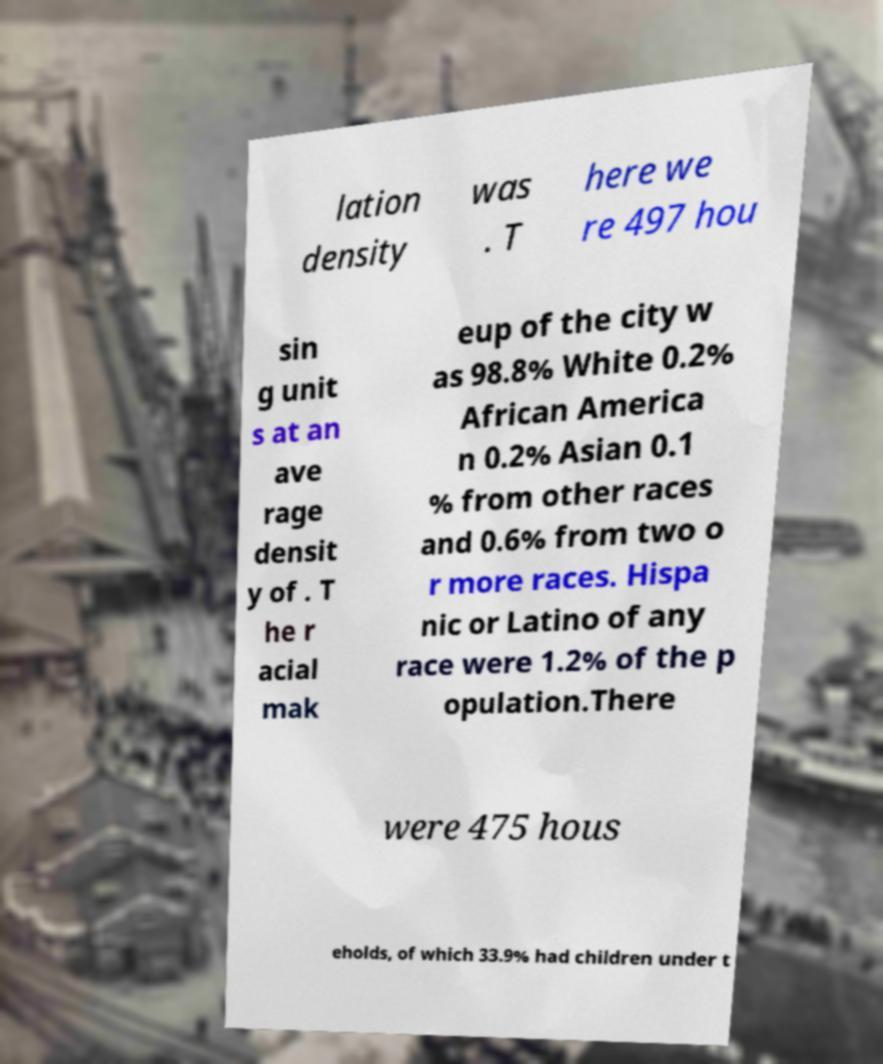Can you read and provide the text displayed in the image?This photo seems to have some interesting text. Can you extract and type it out for me? lation density was . T here we re 497 hou sin g unit s at an ave rage densit y of . T he r acial mak eup of the city w as 98.8% White 0.2% African America n 0.2% Asian 0.1 % from other races and 0.6% from two o r more races. Hispa nic or Latino of any race were 1.2% of the p opulation.There were 475 hous eholds, of which 33.9% had children under t 